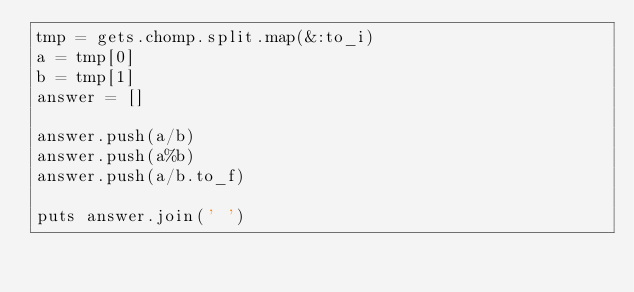Convert code to text. <code><loc_0><loc_0><loc_500><loc_500><_Ruby_>tmp = gets.chomp.split.map(&:to_i)
a = tmp[0]
b = tmp[1]
answer = []

answer.push(a/b)
answer.push(a%b)
answer.push(a/b.to_f)

puts answer.join(' ')</code> 